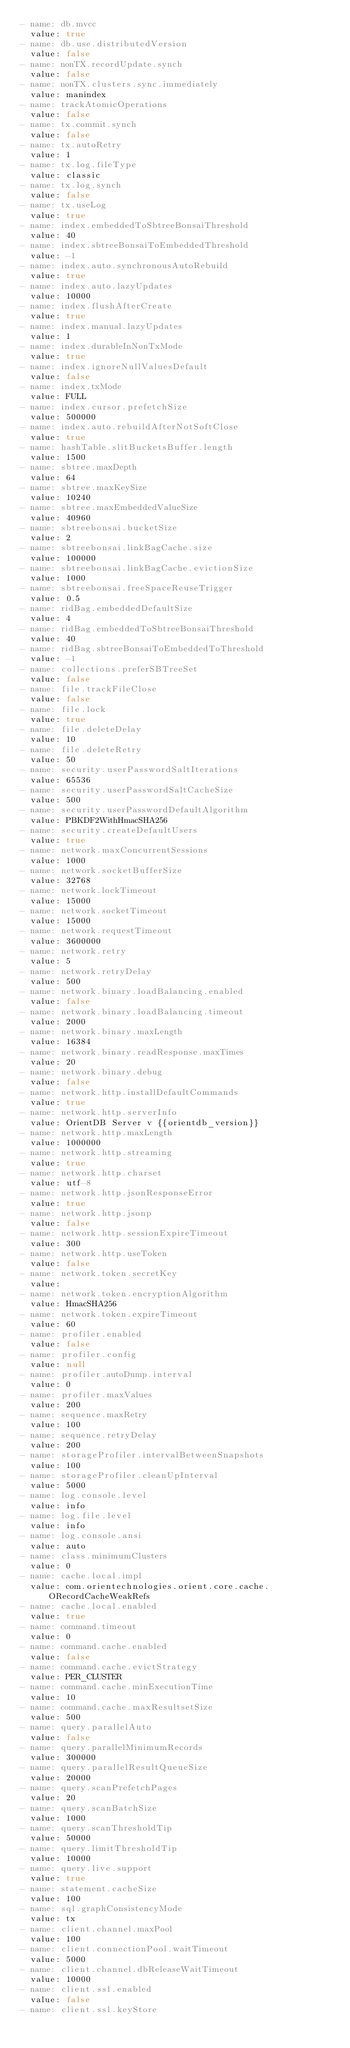<code> <loc_0><loc_0><loc_500><loc_500><_YAML_>- name: db.mvcc
  value: true
- name: db.use.distributedVersion
  value: false
- name: nonTX.recordUpdate.synch
  value: false
- name: nonTX.clusters.sync.immediately
  value: manindex
- name: trackAtomicOperations
  value: false
- name: tx.commit.synch
  value: false
- name: tx.autoRetry
  value: 1
- name: tx.log.fileType
  value: classic
- name: tx.log.synch
  value: false
- name: tx.useLog
  value: true
- name: index.embeddedToSbtreeBonsaiThreshold
  value: 40
- name: index.sbtreeBonsaiToEmbeddedThreshold
  value: -1
- name: index.auto.synchronousAutoRebuild
  value: true
- name: index.auto.lazyUpdates
  value: 10000
- name: index.flushAfterCreate
  value: true
- name: index.manual.lazyUpdates
  value: 1
- name: index.durableInNonTxMode
  value: true
- name: index.ignoreNullValuesDefault
  value: false
- name: index.txMode
  value: FULL
- name: index.cursor.prefetchSize
  value: 500000
- name: index.auto.rebuildAfterNotSoftClose
  value: true
- name: hashTable.slitBucketsBuffer.length
  value: 1500
- name: sbtree.maxDepth
  value: 64
- name: sbtree.maxKeySize
  value: 10240
- name: sbtree.maxEmbeddedValueSize
  value: 40960
- name: sbtreebonsai.bucketSize
  value: 2
- name: sbtreebonsai.linkBagCache.size
  value: 100000
- name: sbtreebonsai.linkBagCache.evictionSize
  value: 1000
- name: sbtreebonsai.freeSpaceReuseTrigger
  value: 0.5
- name: ridBag.embeddedDefaultSize
  value: 4
- name: ridBag.embeddedToSbtreeBonsaiThreshold
  value: 40
- name: ridBag.sbtreeBonsaiToEmbeddedToThreshold
  value: -1
- name: collections.preferSBTreeSet
  value: false
- name: file.trackFileClose
  value: false
- name: file.lock
  value: true
- name: file.deleteDelay
  value: 10
- name: file.deleteRetry
  value: 50
- name: security.userPasswordSaltIterations
  value: 65536
- name: security.userPasswordSaltCacheSize
  value: 500
- name: security.userPasswordDefaultAlgorithm
  value: PBKDF2WithHmacSHA256
- name: security.createDefaultUsers
  value: true
- name: network.maxConcurrentSessions
  value: 1000
- name: network.socketBufferSize
  value: 32768
- name: network.lockTimeout
  value: 15000
- name: network.socketTimeout
  value: 15000
- name: network.requestTimeout
  value: 3600000
- name: network.retry
  value: 5
- name: network.retryDelay
  value: 500
- name: network.binary.loadBalancing.enabled
  value: false
- name: network.binary.loadBalancing.timeout
  value: 2000
- name: network.binary.maxLength
  value: 16384
- name: network.binary.readResponse.maxTimes
  value: 20
- name: network.binary.debug
  value: false
- name: network.http.installDefaultCommands
  value: true
- name: network.http.serverInfo
  value: OrientDB Server v {{orientdb_version}}
- name: network.http.maxLength
  value: 1000000
- name: network.http.streaming
  value: true
- name: network.http.charset
  value: utf-8
- name: network.http.jsonResponseError
  value: true
- name: network.http.jsonp
  value: false
- name: network.http.sessionExpireTimeout
  value: 300
- name: network.http.useToken
  value: false
- name: network.token.secretKey
  value:
- name: network.token.encryptionAlgorithm
  value: HmacSHA256
- name: network.token.expireTimeout
  value: 60
- name: profiler.enabled
  value: false
- name: profiler.config
  value: null
- name: profiler.autoDump.interval
  value: 0
- name: profiler.maxValues
  value: 200
- name: sequence.maxRetry
  value: 100
- name: sequence.retryDelay
  value: 200
- name: storageProfiler.intervalBetweenSnapshots
  value: 100
- name: storageProfiler.cleanUpInterval
  value: 5000
- name: log.console.level
  value: info
- name: log.file.level
  value: info
- name: log.console.ansi
  value: auto
- name: class.minimumClusters
  value: 0
- name: cache.local.impl
  value: com.orientechnologies.orient.core.cache.ORecordCacheWeakRefs
- name: cache.local.enabled
  value: true
- name: command.timeout
  value: 0
- name: command.cache.enabled
  value: false
- name: command.cache.evictStrategy
  value: PER_CLUSTER
- name: command.cache.minExecutionTime
  value: 10
- name: command.cache.maxResultsetSize
  value: 500
- name: query.parallelAuto
  value: false
- name: query.parallelMinimumRecords
  value: 300000
- name: query.parallelResultQueueSize
  value: 20000
- name: query.scanPrefetchPages
  value: 20
- name: query.scanBatchSize
  value: 1000
- name: query.scanThresholdTip
  value: 50000
- name: query.limitThresholdTip
  value: 10000
- name: query.live.support
  value: true
- name: statement.cacheSize
  value: 100
- name: sql.graphConsistencyMode
  value: tx
- name: client.channel.maxPool
  value: 100
- name: client.connectionPool.waitTimeout
  value: 5000
- name: client.channel.dbReleaseWaitTimeout
  value: 10000
- name: client.ssl.enabled
  value: false
- name: client.ssl.keyStore</code> 